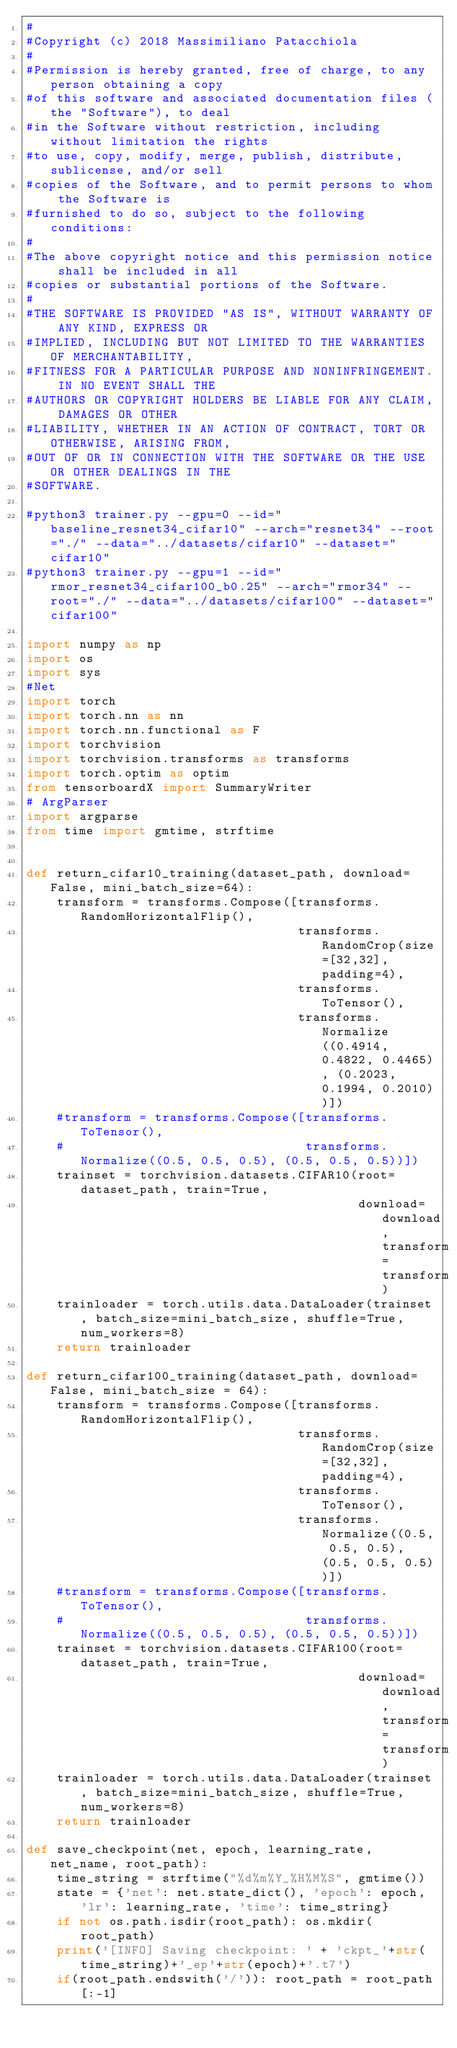Convert code to text. <code><loc_0><loc_0><loc_500><loc_500><_Python_>#
#Copyright (c) 2018 Massimiliano Patacchiola
#
#Permission is hereby granted, free of charge, to any person obtaining a copy
#of this software and associated documentation files (the "Software"), to deal
#in the Software without restriction, including without limitation the rights
#to use, copy, modify, merge, publish, distribute, sublicense, and/or sell
#copies of the Software, and to permit persons to whom the Software is
#furnished to do so, subject to the following conditions:
#
#The above copyright notice and this permission notice shall be included in all
#copies or substantial portions of the Software.
#
#THE SOFTWARE IS PROVIDED "AS IS", WITHOUT WARRANTY OF ANY KIND, EXPRESS OR
#IMPLIED, INCLUDING BUT NOT LIMITED TO THE WARRANTIES OF MERCHANTABILITY,
#FITNESS FOR A PARTICULAR PURPOSE AND NONINFRINGEMENT. IN NO EVENT SHALL THE
#AUTHORS OR COPYRIGHT HOLDERS BE LIABLE FOR ANY CLAIM, DAMAGES OR OTHER
#LIABILITY, WHETHER IN AN ACTION OF CONTRACT, TORT OR OTHERWISE, ARISING FROM,
#OUT OF OR IN CONNECTION WITH THE SOFTWARE OR THE USE OR OTHER DEALINGS IN THE
#SOFTWARE.

#python3 trainer.py --gpu=0 --id="baseline_resnet34_cifar10" --arch="resnet34" --root="./" --data="../datasets/cifar10" --dataset="cifar10"
#python3 trainer.py --gpu=1 --id="rmor_resnet34_cifar100_b0.25" --arch="rmor34" --root="./" --data="../datasets/cifar100" --dataset="cifar100"

import numpy as np
import os
import sys
#Net
import torch
import torch.nn as nn
import torch.nn.functional as F
import torchvision
import torchvision.transforms as transforms
import torch.optim as optim
from tensorboardX import SummaryWriter
# ArgParser
import argparse
from time import gmtime, strftime


def return_cifar10_training(dataset_path, download=False, mini_batch_size=64):
    transform = transforms.Compose([transforms.RandomHorizontalFlip(),
                                    transforms.RandomCrop(size=[32,32], padding=4),
                                    transforms.ToTensor(),
                                    transforms.Normalize((0.4914, 0.4822, 0.4465), (0.2023, 0.1994, 0.2010))])
    #transform = transforms.Compose([transforms.ToTensor(),
    #                                transforms.Normalize((0.5, 0.5, 0.5), (0.5, 0.5, 0.5))])
    trainset = torchvision.datasets.CIFAR10(root=dataset_path, train=True,
                                            download=download, transform=transform)
    trainloader = torch.utils.data.DataLoader(trainset, batch_size=mini_batch_size, shuffle=True, num_workers=8)
    return trainloader

def return_cifar100_training(dataset_path, download=False, mini_batch_size = 64):
    transform = transforms.Compose([transforms.RandomHorizontalFlip(),
                                    transforms.RandomCrop(size=[32,32], padding=4),
                                    transforms.ToTensor(),
                                    transforms.Normalize((0.5, 0.5, 0.5), (0.5, 0.5, 0.5))])
    #transform = transforms.Compose([transforms.ToTensor(),
    #                                transforms.Normalize((0.5, 0.5, 0.5), (0.5, 0.5, 0.5))])
    trainset = torchvision.datasets.CIFAR100(root=dataset_path, train=True,
                                            download=download, transform=transform)
    trainloader = torch.utils.data.DataLoader(trainset, batch_size=mini_batch_size, shuffle=True, num_workers=8)
    return trainloader

def save_checkpoint(net, epoch, learning_rate, net_name, root_path):
    time_string = strftime("%d%m%Y_%H%M%S", gmtime())
    state = {'net': net.state_dict(), 'epoch': epoch, 'lr': learning_rate, 'time': time_string}
    if not os.path.isdir(root_path): os.mkdir(root_path)
    print('[INFO] Saving checkpoint: ' + 'ckpt_'+str(time_string)+'_ep'+str(epoch)+'.t7')
    if(root_path.endswith('/')): root_path = root_path[:-1]</code> 